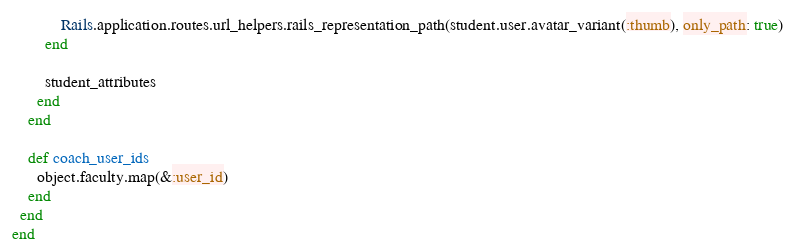Convert code to text. <code><loc_0><loc_0><loc_500><loc_500><_Ruby_>            Rails.application.routes.url_helpers.rails_representation_path(student.user.avatar_variant(:thumb), only_path: true)
        end

        student_attributes
      end
    end

    def coach_user_ids
      object.faculty.map(&:user_id)
    end
  end
end
</code> 